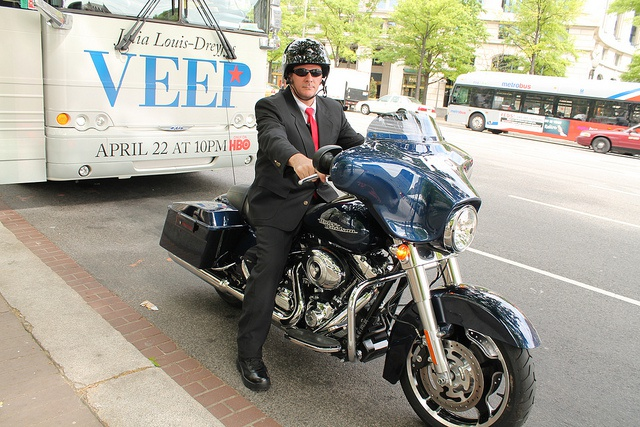Describe the objects in this image and their specific colors. I can see motorcycle in black, gray, lightgray, and darkgray tones, bus in black, ivory, darkgray, lightgray, and lightblue tones, people in black, gray, tan, and brown tones, bus in black, white, gray, darkgray, and salmon tones, and car in black, salmon, lightgray, gray, and brown tones in this image. 